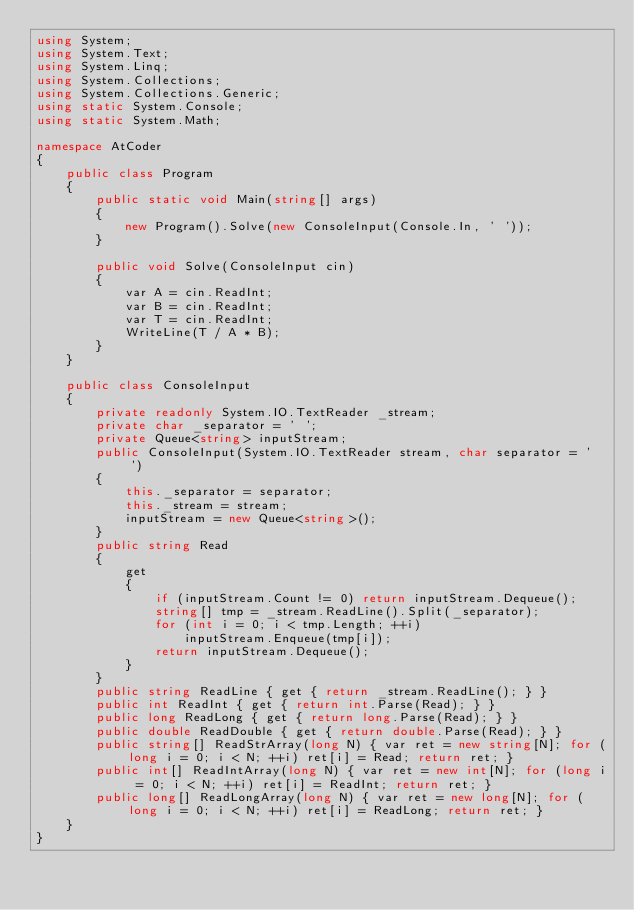Convert code to text. <code><loc_0><loc_0><loc_500><loc_500><_C#_>using System;
using System.Text;
using System.Linq;
using System.Collections;
using System.Collections.Generic;
using static System.Console;
using static System.Math;

namespace AtCoder
{
    public class Program
    {
        public static void Main(string[] args)
        {
            new Program().Solve(new ConsoleInput(Console.In, ' '));
        }

        public void Solve(ConsoleInput cin)
        {
            var A = cin.ReadInt;
            var B = cin.ReadInt;
            var T = cin.ReadInt;
            WriteLine(T / A * B);
        }
    }

    public class ConsoleInput
    {
        private readonly System.IO.TextReader _stream;
        private char _separator = ' ';
        private Queue<string> inputStream;
        public ConsoleInput(System.IO.TextReader stream, char separator = ' ')
        {
            this._separator = separator;
            this._stream = stream;
            inputStream = new Queue<string>();
        }
        public string Read
        {
            get
            {
                if (inputStream.Count != 0) return inputStream.Dequeue();
                string[] tmp = _stream.ReadLine().Split(_separator);
                for (int i = 0; i < tmp.Length; ++i)
                    inputStream.Enqueue(tmp[i]);
                return inputStream.Dequeue();
            }
        }
        public string ReadLine { get { return _stream.ReadLine(); } }
        public int ReadInt { get { return int.Parse(Read); } }
        public long ReadLong { get { return long.Parse(Read); } }
        public double ReadDouble { get { return double.Parse(Read); } }
        public string[] ReadStrArray(long N) { var ret = new string[N]; for (long i = 0; i < N; ++i) ret[i] = Read; return ret; }
        public int[] ReadIntArray(long N) { var ret = new int[N]; for (long i = 0; i < N; ++i) ret[i] = ReadInt; return ret; }
        public long[] ReadLongArray(long N) { var ret = new long[N]; for (long i = 0; i < N; ++i) ret[i] = ReadLong; return ret; }
    }
}</code> 